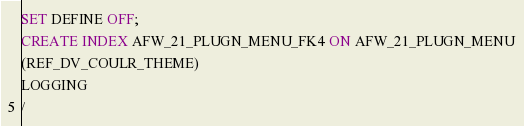Convert code to text. <code><loc_0><loc_0><loc_500><loc_500><_SQL_>SET DEFINE OFF;
CREATE INDEX AFW_21_PLUGN_MENU_FK4 ON AFW_21_PLUGN_MENU
(REF_DV_COULR_THEME)
LOGGING
/
</code> 